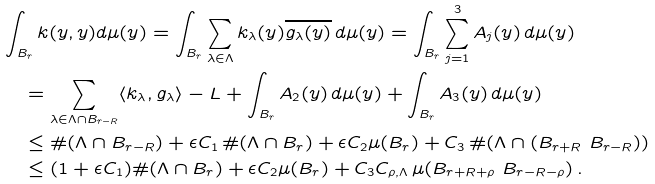<formula> <loc_0><loc_0><loc_500><loc_500>& \int _ { B _ { r } } k ( y , y ) d \mu ( y ) = \int _ { B _ { r } } \sum _ { \lambda \in \Lambda } k _ { \lambda } ( y ) \overline { g _ { \lambda } ( y ) } \, d \mu ( y ) = \int _ { B _ { r } } \sum _ { j = 1 } ^ { 3 } A _ { j } ( y ) \, d \mu ( y ) \\ \ & \quad = \sum _ { \lambda \in \Lambda \cap B _ { r - R } } \langle k _ { \lambda } , g _ { \lambda } \rangle - L + \int _ { B _ { r } } A _ { 2 } ( y ) \, d \mu ( y ) + \int _ { B _ { r } } A _ { 3 } ( y ) \, d \mu ( y ) \\ & \quad \leq \# ( \Lambda \cap B _ { r - R } ) + \epsilon C _ { 1 } \, \# ( \Lambda \cap B _ { r } ) + \epsilon C _ { 2 } \mu ( B _ { r } ) + C _ { 3 } \, \# ( \Lambda \cap ( B _ { r + R } \ B _ { r - R } ) ) \\ & \quad \leq ( 1 + \epsilon C _ { 1 } ) \# ( \Lambda \cap B _ { r } ) + \epsilon C _ { 2 } \mu ( B _ { r } ) + C _ { 3 } C _ { \rho , \Lambda } \, \mu ( B _ { r + R + \rho } \ B _ { r - R - \rho } ) \, .</formula> 